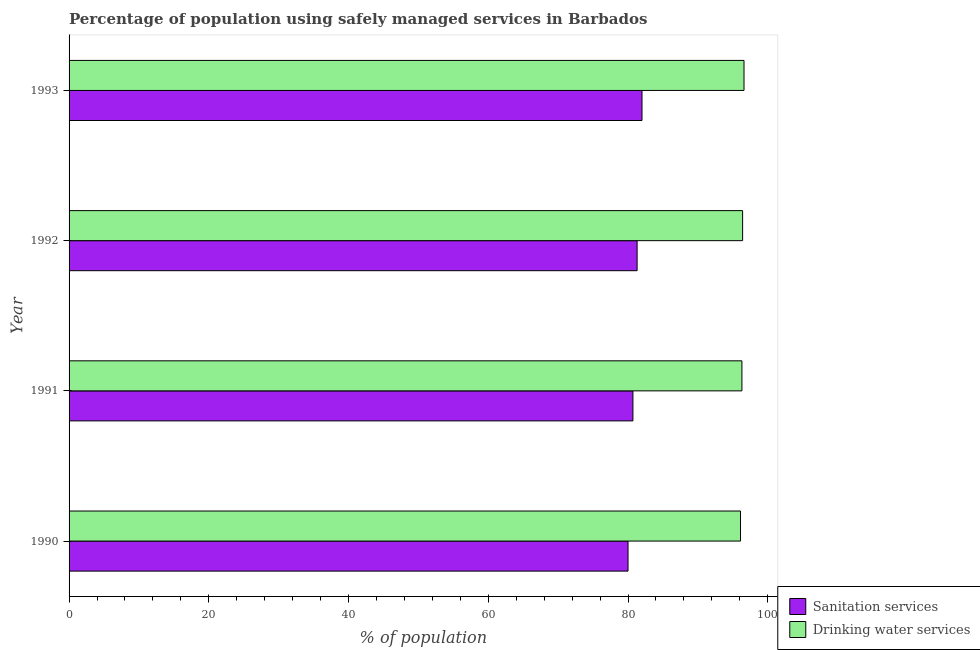How many different coloured bars are there?
Offer a very short reply. 2. Are the number of bars per tick equal to the number of legend labels?
Give a very brief answer. Yes. Are the number of bars on each tick of the Y-axis equal?
Offer a terse response. Yes. How many bars are there on the 1st tick from the top?
Give a very brief answer. 2. What is the label of the 2nd group of bars from the top?
Offer a terse response. 1992. What is the percentage of population who used drinking water services in 1993?
Ensure brevity in your answer.  96.6. Across all years, what is the maximum percentage of population who used drinking water services?
Your answer should be compact. 96.6. What is the total percentage of population who used drinking water services in the graph?
Provide a short and direct response. 385.4. What is the difference between the percentage of population who used drinking water services in 1991 and that in 1993?
Give a very brief answer. -0.3. What is the difference between the percentage of population who used sanitation services in 1992 and the percentage of population who used drinking water services in 1993?
Keep it short and to the point. -15.3. In how many years, is the percentage of population who used sanitation services greater than 24 %?
Make the answer very short. 4. Is the percentage of population who used drinking water services in 1991 less than that in 1993?
Your response must be concise. Yes. In how many years, is the percentage of population who used sanitation services greater than the average percentage of population who used sanitation services taken over all years?
Provide a short and direct response. 2. Is the sum of the percentage of population who used sanitation services in 1992 and 1993 greater than the maximum percentage of population who used drinking water services across all years?
Offer a very short reply. Yes. What does the 1st bar from the top in 1992 represents?
Provide a short and direct response. Drinking water services. What does the 2nd bar from the bottom in 1990 represents?
Offer a terse response. Drinking water services. Are all the bars in the graph horizontal?
Make the answer very short. Yes. How many years are there in the graph?
Make the answer very short. 4. What is the difference between two consecutive major ticks on the X-axis?
Provide a succinct answer. 20. Does the graph contain grids?
Give a very brief answer. No. How are the legend labels stacked?
Your answer should be very brief. Vertical. What is the title of the graph?
Your answer should be compact. Percentage of population using safely managed services in Barbados. Does "Urban" appear as one of the legend labels in the graph?
Provide a succinct answer. No. What is the label or title of the X-axis?
Your response must be concise. % of population. What is the label or title of the Y-axis?
Make the answer very short. Year. What is the % of population of Sanitation services in 1990?
Make the answer very short. 80. What is the % of population in Drinking water services in 1990?
Provide a short and direct response. 96.1. What is the % of population in Sanitation services in 1991?
Ensure brevity in your answer.  80.7. What is the % of population of Drinking water services in 1991?
Your response must be concise. 96.3. What is the % of population of Sanitation services in 1992?
Your response must be concise. 81.3. What is the % of population in Drinking water services in 1992?
Offer a terse response. 96.4. What is the % of population of Sanitation services in 1993?
Provide a succinct answer. 82. What is the % of population of Drinking water services in 1993?
Your response must be concise. 96.6. Across all years, what is the maximum % of population of Drinking water services?
Give a very brief answer. 96.6. Across all years, what is the minimum % of population of Sanitation services?
Your answer should be compact. 80. Across all years, what is the minimum % of population in Drinking water services?
Give a very brief answer. 96.1. What is the total % of population of Sanitation services in the graph?
Your answer should be compact. 324. What is the total % of population in Drinking water services in the graph?
Ensure brevity in your answer.  385.4. What is the difference between the % of population of Drinking water services in 1990 and that in 1991?
Make the answer very short. -0.2. What is the difference between the % of population in Drinking water services in 1990 and that in 1992?
Your response must be concise. -0.3. What is the difference between the % of population in Sanitation services in 1990 and that in 1993?
Your answer should be very brief. -2. What is the difference between the % of population in Drinking water services in 1990 and that in 1993?
Provide a short and direct response. -0.5. What is the difference between the % of population in Sanitation services in 1991 and that in 1992?
Give a very brief answer. -0.6. What is the difference between the % of population of Drinking water services in 1991 and that in 1992?
Your answer should be compact. -0.1. What is the difference between the % of population of Sanitation services in 1990 and the % of population of Drinking water services in 1991?
Keep it short and to the point. -16.3. What is the difference between the % of population of Sanitation services in 1990 and the % of population of Drinking water services in 1992?
Your answer should be compact. -16.4. What is the difference between the % of population in Sanitation services in 1990 and the % of population in Drinking water services in 1993?
Make the answer very short. -16.6. What is the difference between the % of population of Sanitation services in 1991 and the % of population of Drinking water services in 1992?
Your answer should be compact. -15.7. What is the difference between the % of population of Sanitation services in 1991 and the % of population of Drinking water services in 1993?
Keep it short and to the point. -15.9. What is the difference between the % of population in Sanitation services in 1992 and the % of population in Drinking water services in 1993?
Provide a succinct answer. -15.3. What is the average % of population in Drinking water services per year?
Provide a short and direct response. 96.35. In the year 1990, what is the difference between the % of population of Sanitation services and % of population of Drinking water services?
Your answer should be compact. -16.1. In the year 1991, what is the difference between the % of population in Sanitation services and % of population in Drinking water services?
Keep it short and to the point. -15.6. In the year 1992, what is the difference between the % of population in Sanitation services and % of population in Drinking water services?
Provide a short and direct response. -15.1. In the year 1993, what is the difference between the % of population in Sanitation services and % of population in Drinking water services?
Give a very brief answer. -14.6. What is the ratio of the % of population in Sanitation services in 1990 to that in 1991?
Offer a very short reply. 0.99. What is the ratio of the % of population of Drinking water services in 1990 to that in 1991?
Give a very brief answer. 1. What is the ratio of the % of population in Sanitation services in 1990 to that in 1992?
Keep it short and to the point. 0.98. What is the ratio of the % of population of Drinking water services in 1990 to that in 1992?
Your answer should be compact. 1. What is the ratio of the % of population of Sanitation services in 1990 to that in 1993?
Your answer should be very brief. 0.98. What is the ratio of the % of population in Sanitation services in 1991 to that in 1992?
Provide a short and direct response. 0.99. What is the ratio of the % of population of Drinking water services in 1991 to that in 1992?
Offer a very short reply. 1. What is the ratio of the % of population in Sanitation services in 1991 to that in 1993?
Your response must be concise. 0.98. What is the ratio of the % of population in Drinking water services in 1992 to that in 1993?
Provide a short and direct response. 1. What is the difference between the highest and the second highest % of population in Drinking water services?
Your answer should be very brief. 0.2. What is the difference between the highest and the lowest % of population of Sanitation services?
Keep it short and to the point. 2. 